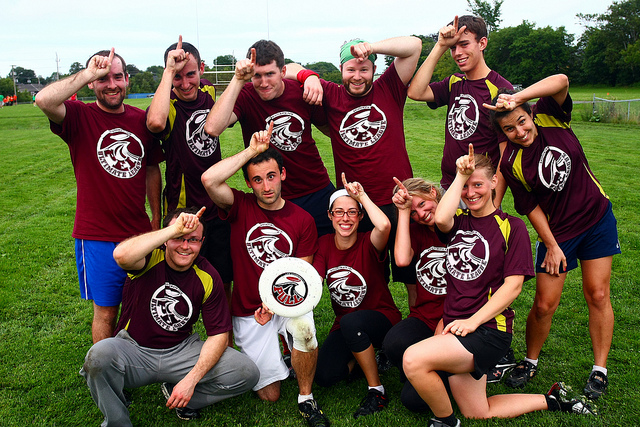Identify the text displayed in this image. PE I PE PEI PULL PEI PEI PE E 